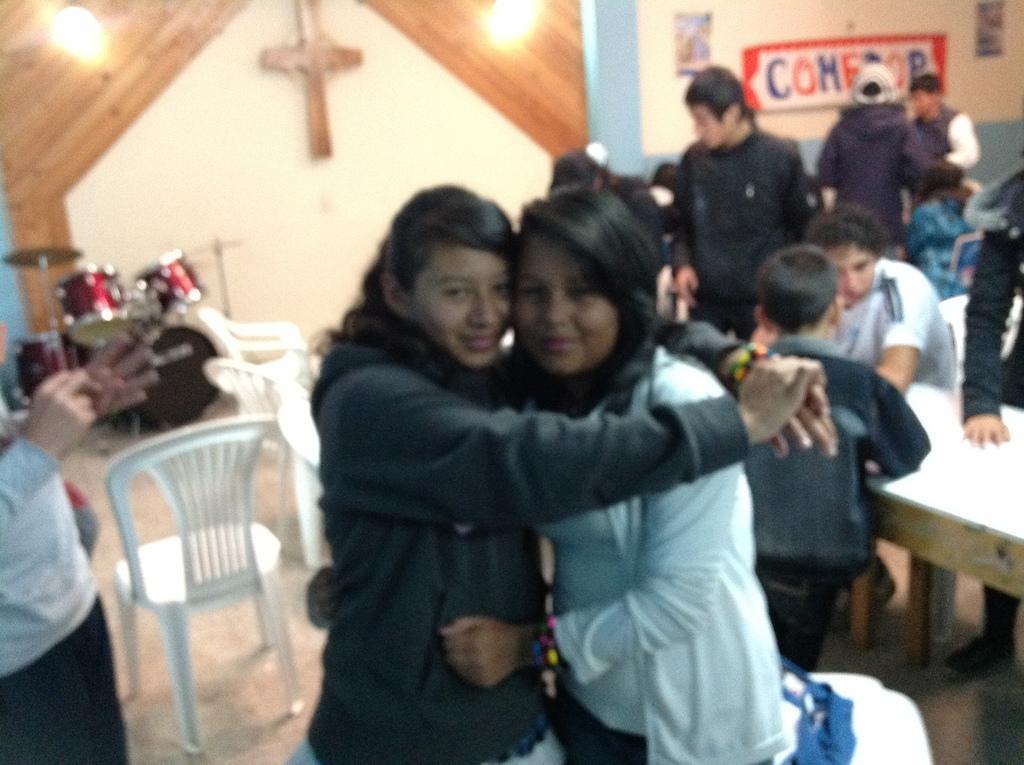Can you describe this image briefly? There is a room which includes chairs, musical instrument at the top-left corner, table at the right side and a group of persons in which two of them are standing in the center and smiling and on the right side there is a person sitting on the chair and in the background there are group of people in which two of them are standing and one of them is sitting and in the left corner there is a person standing. 